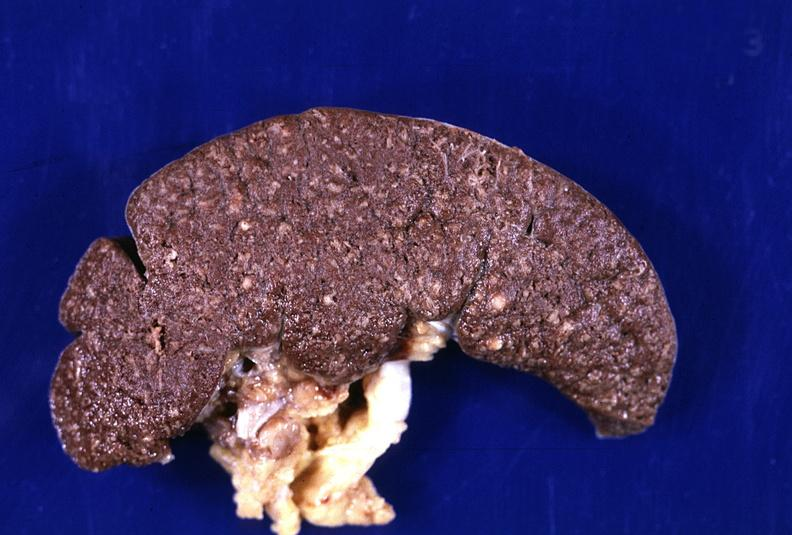s hematologic present?
Answer the question using a single word or phrase. Yes 